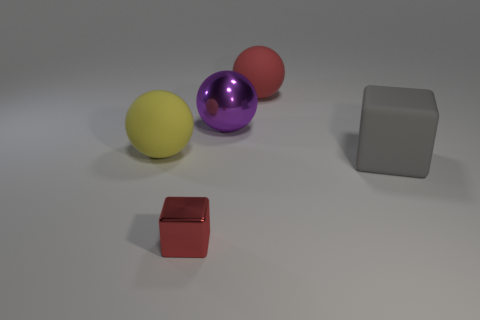Are there any purple objects that have the same size as the metallic block? Yes, there appears to be a purple ball that is roughly the same size as the metallic block on the right. 